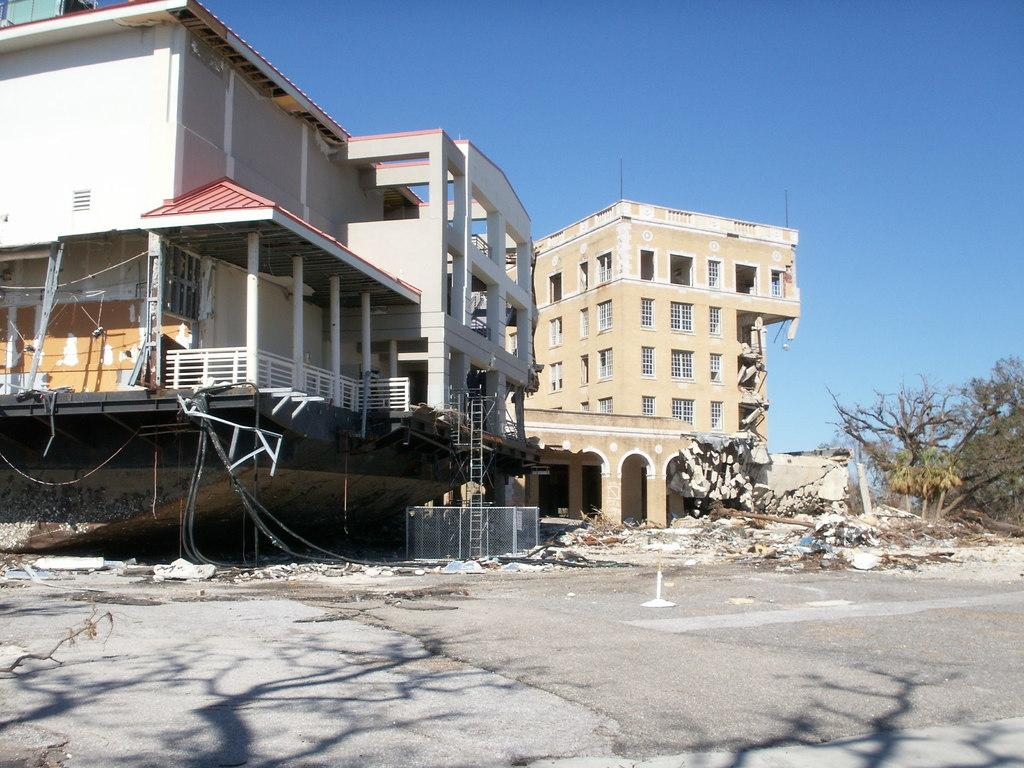What type of structures can be seen in the image? There are buildings in the image. Can you identify any specific condition of one of the buildings? One of the buildings is under renovation. What type of vegetation is on the right side of the image? There are trees on the right side of the image. What is visible in the background of the image? The sky is visible in the image. What type of pathway is present in the image? There is a road in the image. What type of badge is being worn by the tree on the right side of the image? There are no badges present in the image, as the tree is a natural object and not a person or entity that would wear a badge. 